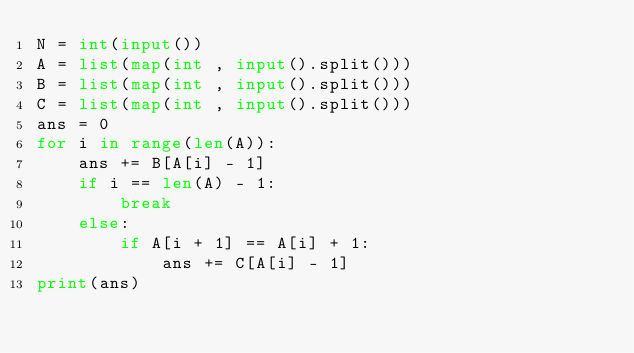Convert code to text. <code><loc_0><loc_0><loc_500><loc_500><_Python_>N = int(input())
A = list(map(int , input().split()))
B = list(map(int , input().split()))
C = list(map(int , input().split()))
ans = 0
for i in range(len(A)):
    ans += B[A[i] - 1]
    if i == len(A) - 1:
        break
    else:
        if A[i + 1] == A[i] + 1:
            ans += C[A[i] - 1]
print(ans)
</code> 